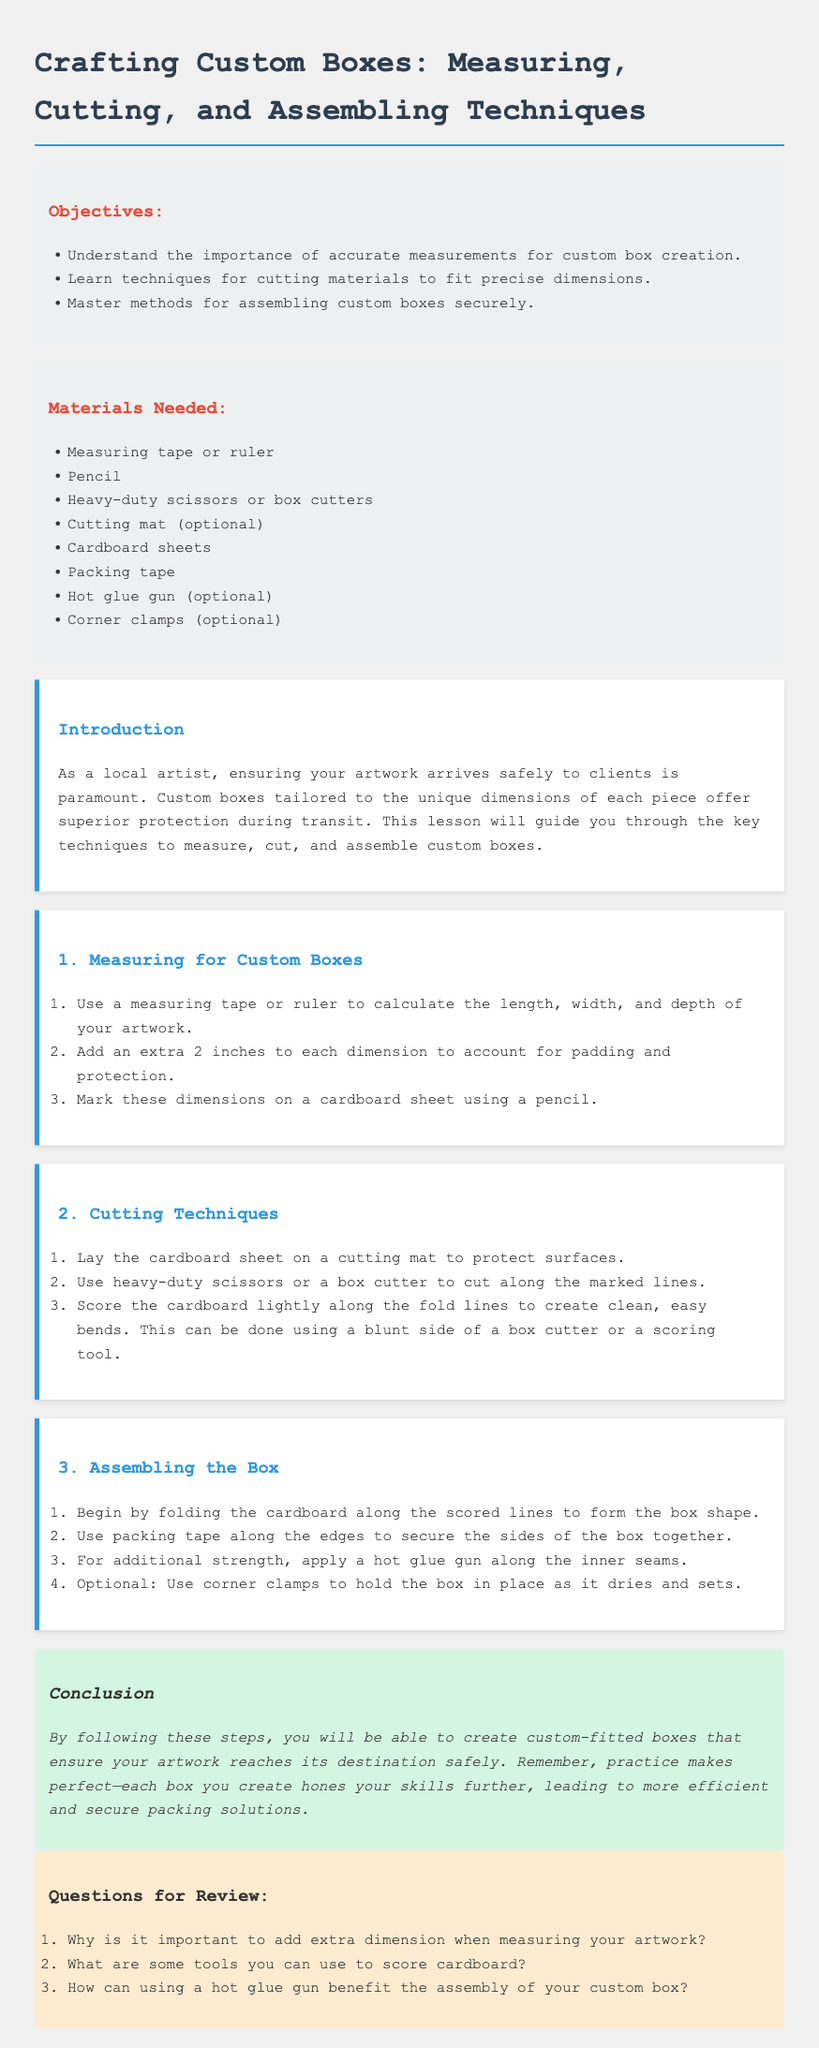What are the objectives of the lesson? The objectives outline what learners will achieve through the lesson, emphasizing accurate measurements, cutting techniques, and assembling methods.
Answer: Understand the importance of accurate measurements for custom box creation, Learn techniques for cutting materials to fit precise dimensions, Master methods for assembling custom boxes securely What is the first step in measuring for custom boxes? The document specifies the initial action learners should take when measuring for custom boxes, which is to use a measuring tape or ruler.
Answer: Use a measuring tape or ruler to calculate the length, width, and depth of your artwork Which tool is optional for cutting the cardboard? The document lists various materials needed, including those that are optional for completing the task.
Answer: Cutting mat What should be added to each dimension during measurement? The reason for adjusting the measurements is provided in the document to ensure proper fit and protection for the artwork.
Answer: An extra 2 inches What additional method can secure the box during assembly? The document explains an optional method that strengthens the assembly of the box beyond the primary adhesive.
Answer: Use corner clamps What is the main purpose of this lesson plan? The document clearly states that the purpose is to guide artists on how to create secure packaging for their artwork.
Answer: Ensuring your artwork arrives safely to clients 